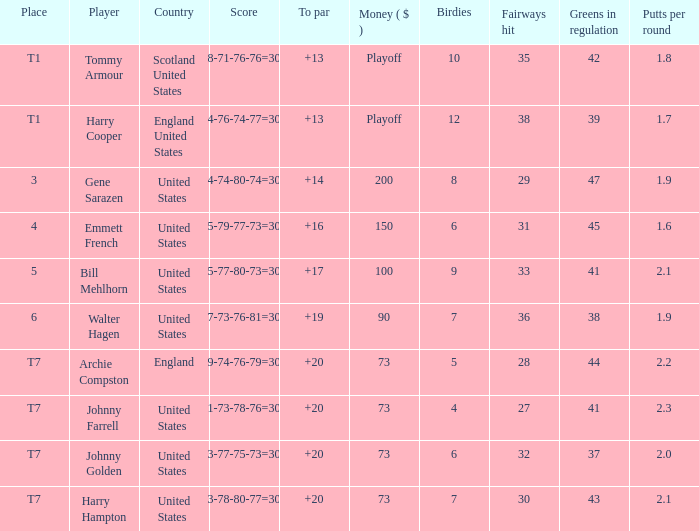What is the ranking when Archie Compston is the player and the money is $73? T7. Would you be able to parse every entry in this table? {'header': ['Place', 'Player', 'Country', 'Score', 'To par', 'Money ( $ )', 'Birdies', 'Fairways hit', 'Greens in regulation', 'Putts per round'], 'rows': [['T1', 'Tommy Armour', 'Scotland United States', '78-71-76-76=301', '+13', 'Playoff', '10', '35', '42', '1.8'], ['T1', 'Harry Cooper', 'England United States', '74-76-74-77=301', '+13', 'Playoff', '12', '38', '39', '1.7'], ['3', 'Gene Sarazen', 'United States', '74-74-80-74=302', '+14', '200', '8', '29', '47', '1.9'], ['4', 'Emmett French', 'United States', '75-79-77-73=304', '+16', '150', '6', '31', '45', '1.6'], ['5', 'Bill Mehlhorn', 'United States', '75-77-80-73=305', '+17', '100', '9', '33', '41', '2.1'], ['6', 'Walter Hagen', 'United States', '77-73-76-81=307', '+19', '90', '7', '36', '38', '1.9'], ['T7', 'Archie Compston', 'England', '79-74-76-79=308', '+20', '73', '5', '28', '44', '2.2'], ['T7', 'Johnny Farrell', 'United States', '81-73-78-76=308', '+20', '73', '4', '27', '41', '2.3'], ['T7', 'Johnny Golden', 'United States', '83-77-75-73=308', '+20', '73', '6', '32', '37', '2.0'], ['T7', 'Harry Hampton', 'United States', '73-78-80-77=308', '+20', '73', '7', '30', '43', '2.1']]} 